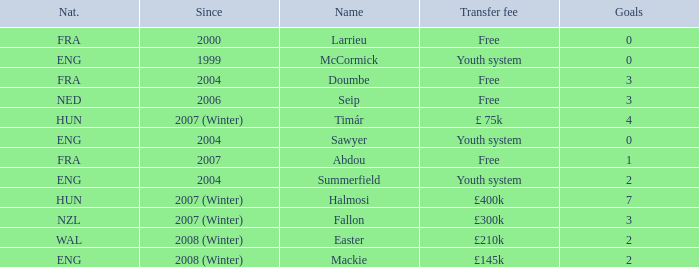Could you parse the entire table as a dict? {'header': ['Nat.', 'Since', 'Name', 'Transfer fee', 'Goals'], 'rows': [['FRA', '2000', 'Larrieu', 'Free', '0'], ['ENG', '1999', 'McCormick', 'Youth system', '0'], ['FRA', '2004', 'Doumbe', 'Free', '3'], ['NED', '2006', 'Seip', 'Free', '3'], ['HUN', '2007 (Winter)', 'Timár', '£ 75k', '4'], ['ENG', '2004', 'Sawyer', 'Youth system', '0'], ['FRA', '2007', 'Abdou', 'Free', '1'], ['ENG', '2004', 'Summerfield', 'Youth system', '2'], ['HUN', '2007 (Winter)', 'Halmosi', '£400k', '7'], ['NZL', '2007 (Winter)', 'Fallon', '£300k', '3'], ['WAL', '2008 (Winter)', 'Easter', '£210k', '2'], ['ENG', '2008 (Winter)', 'Mackie', '£145k', '2']]} On average, how many goals does sawyer have? 0.0. 